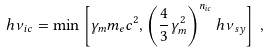<formula> <loc_0><loc_0><loc_500><loc_500>h \nu _ { i c } = \min \left [ \gamma _ { m } m _ { e } c ^ { 2 } , \left ( \frac { 4 } { 3 } \gamma _ { m } ^ { 2 } \right ) ^ { n _ { i c } } h \nu _ { s y } \right ] \, ,</formula> 